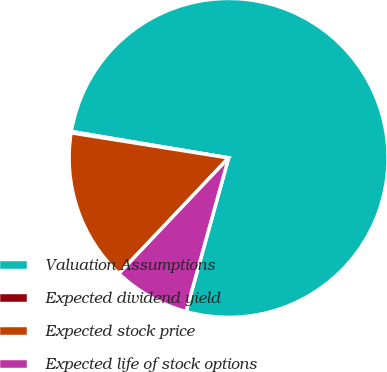Convert chart to OTSL. <chart><loc_0><loc_0><loc_500><loc_500><pie_chart><fcel>Valuation Assumptions<fcel>Expected dividend yield<fcel>Expected stock price<fcel>Expected life of stock options<nl><fcel>76.65%<fcel>0.13%<fcel>15.44%<fcel>7.78%<nl></chart> 